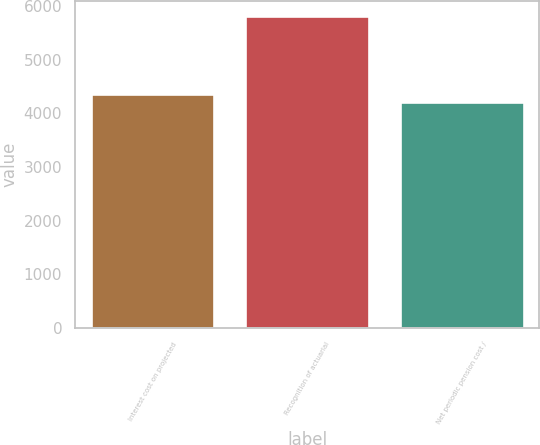Convert chart. <chart><loc_0><loc_0><loc_500><loc_500><bar_chart><fcel>Interest cost on projected<fcel>Recognition of actuarial<fcel>Net periodic pension cost /<nl><fcel>4366.7<fcel>5804<fcel>4207<nl></chart> 